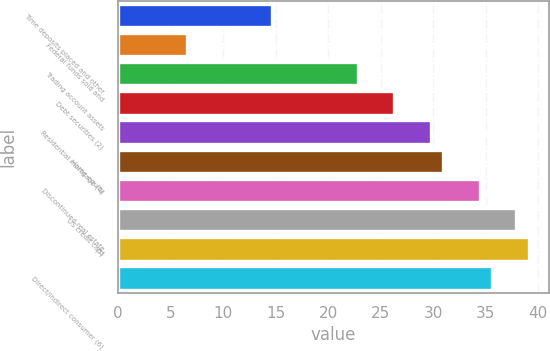Convert chart. <chart><loc_0><loc_0><loc_500><loc_500><bar_chart><fcel>Time deposits placed and other<fcel>Federal funds sold and<fcel>Trading account assets<fcel>Debt securities (2)<fcel>Residential mortgage (4)<fcel>Home equity<fcel>Discontinued real estate<fcel>US credit card<fcel>(5)<fcel>Direct/Indirect consumer (6)<nl><fcel>14.68<fcel>6.54<fcel>22.8<fcel>26.29<fcel>29.77<fcel>30.93<fcel>34.42<fcel>37.92<fcel>39.09<fcel>35.59<nl></chart> 